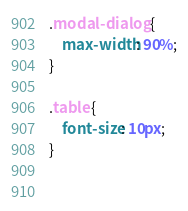Convert code to text. <code><loc_0><loc_0><loc_500><loc_500><_CSS_>.modal-dialog {
    max-width: 90%;
}

.table {
    font-size: 10px;
}

 </code> 